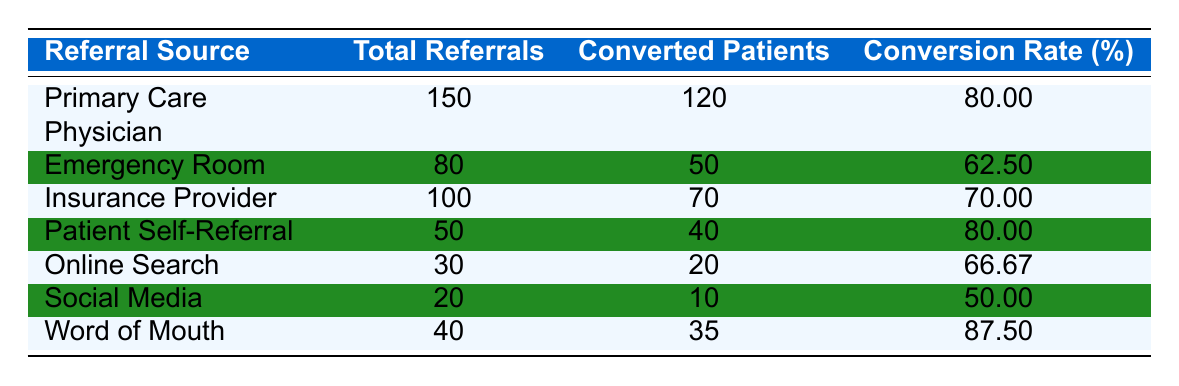What is the conversion rate for referrals from the Primary Care Physician? The conversion rate for the Primary Care Physician referral source is explicitly listed in the table as 80.00%.
Answer: 80.00% How many converted patients came from the Word of Mouth referrals? The number of converted patients from the Word of Mouth referrals is provided in the table as 35.
Answer: 35 What is the total number of referrals from the Emergency Room? The total number of referrals from the Emergency Room is given in the table as 80.
Answer: 80 Which referral source has the highest conversion rate? From the table data, Word of Mouth has the highest conversion rate at 87.50%. To find this, we compare the conversion rates of all referral sources.
Answer: Word of Mouth Is the conversion rate for Patient Self-Referral higher than that for Social Media? The conversion rate for Patient Self-Referral is 80.00%, while for Social Media it is 50.00%. Since 80.00% is greater than 50.00%, the statement is true.
Answer: Yes How many total referrals were there across all sources? To find the total referrals across all sources, we add the total referrals from each source: 150 + 80 + 100 + 50 + 30 + 20 + 40 = 470. This calculation sums up all the values from the Total Referrals column.
Answer: 470 What was the average conversion rate for the listed referral sources? To find the average conversion rate, we add all conversion rates: 80 + 62.5 + 70 + 80 + 66.67 + 50 + 87.5 = 496.67. There are 7 sources, so the average is 496.67 / 7 = 70.95 (rounded to two decimals).
Answer: 70.95 If the total number of referrals from Online Search and Social Media were combined, what would the combined conversion rate be? The total referrals from Online Search are 30 and from Social Media are 20, equaling 50 total referrals. The total converted patients would be 20 (Online Search) + 10 (Social Media) = 30. Therefore, the conversion rate is (30/50) * 100 = 60%.
Answer: 60% 